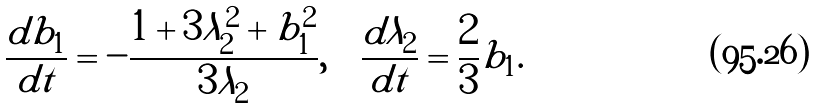Convert formula to latex. <formula><loc_0><loc_0><loc_500><loc_500>\frac { d b _ { 1 } } { d t } = - \frac { 1 + 3 \lambda _ { 2 } ^ { 2 } + b _ { 1 } ^ { 2 } } { 3 \lambda _ { 2 } } , \quad \frac { d \lambda _ { 2 } } { d t } = \frac { 2 } { 3 } b _ { 1 } .</formula> 